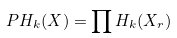<formula> <loc_0><loc_0><loc_500><loc_500>P H _ { k } ( X ) = \prod H _ { k } ( X _ { r } )</formula> 